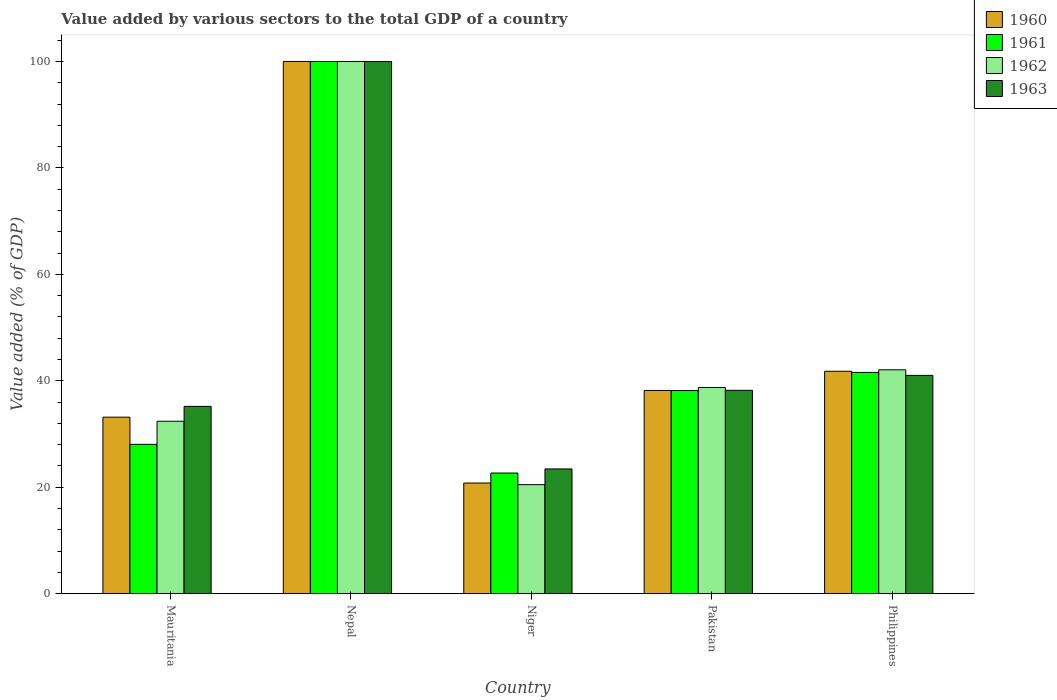How many different coloured bars are there?
Ensure brevity in your answer.  4. Are the number of bars per tick equal to the number of legend labels?
Provide a short and direct response. Yes. How many bars are there on the 2nd tick from the left?
Keep it short and to the point. 4. How many bars are there on the 1st tick from the right?
Your response must be concise. 4. What is the label of the 2nd group of bars from the left?
Offer a very short reply. Nepal. What is the value added by various sectors to the total GDP in 1963 in Nepal?
Ensure brevity in your answer.  100. Across all countries, what is the minimum value added by various sectors to the total GDP in 1960?
Make the answer very short. 20.79. In which country was the value added by various sectors to the total GDP in 1961 maximum?
Make the answer very short. Nepal. In which country was the value added by various sectors to the total GDP in 1960 minimum?
Give a very brief answer. Niger. What is the total value added by various sectors to the total GDP in 1962 in the graph?
Your answer should be very brief. 233.69. What is the difference between the value added by various sectors to the total GDP in 1963 in Niger and that in Philippines?
Offer a very short reply. -17.58. What is the difference between the value added by various sectors to the total GDP in 1963 in Mauritania and the value added by various sectors to the total GDP in 1961 in Philippines?
Offer a terse response. -6.38. What is the average value added by various sectors to the total GDP in 1962 per country?
Your answer should be compact. 46.74. What is the difference between the value added by various sectors to the total GDP of/in 1960 and value added by various sectors to the total GDP of/in 1962 in Pakistan?
Provide a succinct answer. -0.56. In how many countries, is the value added by various sectors to the total GDP in 1962 greater than 68 %?
Make the answer very short. 1. What is the ratio of the value added by various sectors to the total GDP in 1961 in Pakistan to that in Philippines?
Your answer should be very brief. 0.92. Is the value added by various sectors to the total GDP in 1960 in Mauritania less than that in Philippines?
Your answer should be compact. Yes. What is the difference between the highest and the second highest value added by various sectors to the total GDP in 1963?
Provide a succinct answer. -58.99. What is the difference between the highest and the lowest value added by various sectors to the total GDP in 1960?
Give a very brief answer. 79.21. Is the sum of the value added by various sectors to the total GDP in 1961 in Niger and Philippines greater than the maximum value added by various sectors to the total GDP in 1963 across all countries?
Your response must be concise. No. Is it the case that in every country, the sum of the value added by various sectors to the total GDP in 1961 and value added by various sectors to the total GDP in 1960 is greater than the sum of value added by various sectors to the total GDP in 1962 and value added by various sectors to the total GDP in 1963?
Offer a terse response. No. What does the 2nd bar from the left in Philippines represents?
Your answer should be very brief. 1961. What does the 1st bar from the right in Mauritania represents?
Your answer should be very brief. 1963. How many bars are there?
Provide a succinct answer. 20. Are all the bars in the graph horizontal?
Provide a short and direct response. No. How many countries are there in the graph?
Ensure brevity in your answer.  5. Does the graph contain any zero values?
Keep it short and to the point. No. How many legend labels are there?
Offer a terse response. 4. How are the legend labels stacked?
Keep it short and to the point. Vertical. What is the title of the graph?
Keep it short and to the point. Value added by various sectors to the total GDP of a country. Does "2012" appear as one of the legend labels in the graph?
Ensure brevity in your answer.  No. What is the label or title of the Y-axis?
Provide a succinct answer. Value added (% of GDP). What is the Value added (% of GDP) in 1960 in Mauritania?
Give a very brief answer. 33.17. What is the Value added (% of GDP) in 1961 in Mauritania?
Your answer should be compact. 28.06. What is the Value added (% of GDP) of 1962 in Mauritania?
Give a very brief answer. 32.4. What is the Value added (% of GDP) of 1963 in Mauritania?
Your answer should be compact. 35.19. What is the Value added (% of GDP) in 1961 in Nepal?
Make the answer very short. 100. What is the Value added (% of GDP) in 1960 in Niger?
Your response must be concise. 20.79. What is the Value added (% of GDP) of 1961 in Niger?
Make the answer very short. 22.67. What is the Value added (% of GDP) in 1962 in Niger?
Provide a short and direct response. 20.48. What is the Value added (% of GDP) of 1963 in Niger?
Your response must be concise. 23.44. What is the Value added (% of GDP) in 1960 in Pakistan?
Offer a terse response. 38.18. What is the Value added (% of GDP) in 1961 in Pakistan?
Give a very brief answer. 38.17. What is the Value added (% of GDP) in 1962 in Pakistan?
Your response must be concise. 38.74. What is the Value added (% of GDP) of 1963 in Pakistan?
Offer a very short reply. 38.21. What is the Value added (% of GDP) of 1960 in Philippines?
Provide a short and direct response. 41.79. What is the Value added (% of GDP) of 1961 in Philippines?
Make the answer very short. 41.57. What is the Value added (% of GDP) of 1962 in Philippines?
Offer a very short reply. 42.06. What is the Value added (% of GDP) in 1963 in Philippines?
Provide a succinct answer. 41.01. Across all countries, what is the maximum Value added (% of GDP) of 1962?
Offer a terse response. 100. Across all countries, what is the minimum Value added (% of GDP) of 1960?
Give a very brief answer. 20.79. Across all countries, what is the minimum Value added (% of GDP) of 1961?
Give a very brief answer. 22.67. Across all countries, what is the minimum Value added (% of GDP) of 1962?
Provide a short and direct response. 20.48. Across all countries, what is the minimum Value added (% of GDP) of 1963?
Give a very brief answer. 23.44. What is the total Value added (% of GDP) of 1960 in the graph?
Make the answer very short. 233.93. What is the total Value added (% of GDP) in 1961 in the graph?
Your response must be concise. 230.47. What is the total Value added (% of GDP) in 1962 in the graph?
Make the answer very short. 233.69. What is the total Value added (% of GDP) of 1963 in the graph?
Provide a short and direct response. 237.85. What is the difference between the Value added (% of GDP) in 1960 in Mauritania and that in Nepal?
Your answer should be very brief. -66.83. What is the difference between the Value added (% of GDP) in 1961 in Mauritania and that in Nepal?
Make the answer very short. -71.94. What is the difference between the Value added (% of GDP) in 1962 in Mauritania and that in Nepal?
Keep it short and to the point. -67.6. What is the difference between the Value added (% of GDP) of 1963 in Mauritania and that in Nepal?
Provide a short and direct response. -64.81. What is the difference between the Value added (% of GDP) of 1960 in Mauritania and that in Niger?
Ensure brevity in your answer.  12.38. What is the difference between the Value added (% of GDP) in 1961 in Mauritania and that in Niger?
Keep it short and to the point. 5.39. What is the difference between the Value added (% of GDP) in 1962 in Mauritania and that in Niger?
Offer a very short reply. 11.91. What is the difference between the Value added (% of GDP) in 1963 in Mauritania and that in Niger?
Provide a succinct answer. 11.75. What is the difference between the Value added (% of GDP) in 1960 in Mauritania and that in Pakistan?
Offer a terse response. -5.02. What is the difference between the Value added (% of GDP) of 1961 in Mauritania and that in Pakistan?
Your answer should be compact. -10.11. What is the difference between the Value added (% of GDP) of 1962 in Mauritania and that in Pakistan?
Your response must be concise. -6.35. What is the difference between the Value added (% of GDP) in 1963 in Mauritania and that in Pakistan?
Offer a very short reply. -3.02. What is the difference between the Value added (% of GDP) of 1960 in Mauritania and that in Philippines?
Provide a short and direct response. -8.63. What is the difference between the Value added (% of GDP) in 1961 in Mauritania and that in Philippines?
Keep it short and to the point. -13.52. What is the difference between the Value added (% of GDP) in 1962 in Mauritania and that in Philippines?
Offer a very short reply. -9.67. What is the difference between the Value added (% of GDP) of 1963 in Mauritania and that in Philippines?
Provide a short and direct response. -5.82. What is the difference between the Value added (% of GDP) in 1960 in Nepal and that in Niger?
Give a very brief answer. 79.21. What is the difference between the Value added (% of GDP) in 1961 in Nepal and that in Niger?
Give a very brief answer. 77.33. What is the difference between the Value added (% of GDP) in 1962 in Nepal and that in Niger?
Make the answer very short. 79.52. What is the difference between the Value added (% of GDP) of 1963 in Nepal and that in Niger?
Offer a very short reply. 76.56. What is the difference between the Value added (% of GDP) in 1960 in Nepal and that in Pakistan?
Provide a succinct answer. 61.82. What is the difference between the Value added (% of GDP) in 1961 in Nepal and that in Pakistan?
Keep it short and to the point. 61.83. What is the difference between the Value added (% of GDP) of 1962 in Nepal and that in Pakistan?
Keep it short and to the point. 61.26. What is the difference between the Value added (% of GDP) in 1963 in Nepal and that in Pakistan?
Your answer should be compact. 61.79. What is the difference between the Value added (% of GDP) of 1960 in Nepal and that in Philippines?
Offer a terse response. 58.21. What is the difference between the Value added (% of GDP) of 1961 in Nepal and that in Philippines?
Offer a terse response. 58.42. What is the difference between the Value added (% of GDP) of 1962 in Nepal and that in Philippines?
Your answer should be compact. 57.94. What is the difference between the Value added (% of GDP) of 1963 in Nepal and that in Philippines?
Give a very brief answer. 58.99. What is the difference between the Value added (% of GDP) in 1960 in Niger and that in Pakistan?
Make the answer very short. -17.39. What is the difference between the Value added (% of GDP) in 1961 in Niger and that in Pakistan?
Make the answer very short. -15.5. What is the difference between the Value added (% of GDP) of 1962 in Niger and that in Pakistan?
Offer a very short reply. -18.26. What is the difference between the Value added (% of GDP) of 1963 in Niger and that in Pakistan?
Keep it short and to the point. -14.77. What is the difference between the Value added (% of GDP) in 1960 in Niger and that in Philippines?
Offer a very short reply. -21. What is the difference between the Value added (% of GDP) of 1961 in Niger and that in Philippines?
Keep it short and to the point. -18.91. What is the difference between the Value added (% of GDP) of 1962 in Niger and that in Philippines?
Make the answer very short. -21.58. What is the difference between the Value added (% of GDP) of 1963 in Niger and that in Philippines?
Your answer should be very brief. -17.58. What is the difference between the Value added (% of GDP) of 1960 in Pakistan and that in Philippines?
Give a very brief answer. -3.61. What is the difference between the Value added (% of GDP) of 1961 in Pakistan and that in Philippines?
Make the answer very short. -3.41. What is the difference between the Value added (% of GDP) in 1962 in Pakistan and that in Philippines?
Your answer should be very brief. -3.32. What is the difference between the Value added (% of GDP) in 1963 in Pakistan and that in Philippines?
Offer a very short reply. -2.81. What is the difference between the Value added (% of GDP) of 1960 in Mauritania and the Value added (% of GDP) of 1961 in Nepal?
Ensure brevity in your answer.  -66.83. What is the difference between the Value added (% of GDP) in 1960 in Mauritania and the Value added (% of GDP) in 1962 in Nepal?
Make the answer very short. -66.83. What is the difference between the Value added (% of GDP) of 1960 in Mauritania and the Value added (% of GDP) of 1963 in Nepal?
Offer a very short reply. -66.83. What is the difference between the Value added (% of GDP) of 1961 in Mauritania and the Value added (% of GDP) of 1962 in Nepal?
Keep it short and to the point. -71.94. What is the difference between the Value added (% of GDP) of 1961 in Mauritania and the Value added (% of GDP) of 1963 in Nepal?
Your answer should be compact. -71.94. What is the difference between the Value added (% of GDP) in 1962 in Mauritania and the Value added (% of GDP) in 1963 in Nepal?
Your answer should be compact. -67.6. What is the difference between the Value added (% of GDP) in 1960 in Mauritania and the Value added (% of GDP) in 1961 in Niger?
Provide a short and direct response. 10.5. What is the difference between the Value added (% of GDP) in 1960 in Mauritania and the Value added (% of GDP) in 1962 in Niger?
Keep it short and to the point. 12.68. What is the difference between the Value added (% of GDP) in 1960 in Mauritania and the Value added (% of GDP) in 1963 in Niger?
Offer a terse response. 9.73. What is the difference between the Value added (% of GDP) in 1961 in Mauritania and the Value added (% of GDP) in 1962 in Niger?
Your answer should be very brief. 7.58. What is the difference between the Value added (% of GDP) in 1961 in Mauritania and the Value added (% of GDP) in 1963 in Niger?
Ensure brevity in your answer.  4.62. What is the difference between the Value added (% of GDP) in 1962 in Mauritania and the Value added (% of GDP) in 1963 in Niger?
Keep it short and to the point. 8.96. What is the difference between the Value added (% of GDP) in 1960 in Mauritania and the Value added (% of GDP) in 1961 in Pakistan?
Provide a succinct answer. -5. What is the difference between the Value added (% of GDP) of 1960 in Mauritania and the Value added (% of GDP) of 1962 in Pakistan?
Offer a terse response. -5.58. What is the difference between the Value added (% of GDP) in 1960 in Mauritania and the Value added (% of GDP) in 1963 in Pakistan?
Provide a succinct answer. -5.04. What is the difference between the Value added (% of GDP) of 1961 in Mauritania and the Value added (% of GDP) of 1962 in Pakistan?
Give a very brief answer. -10.69. What is the difference between the Value added (% of GDP) of 1961 in Mauritania and the Value added (% of GDP) of 1963 in Pakistan?
Keep it short and to the point. -10.15. What is the difference between the Value added (% of GDP) in 1962 in Mauritania and the Value added (% of GDP) in 1963 in Pakistan?
Offer a terse response. -5.81. What is the difference between the Value added (% of GDP) in 1960 in Mauritania and the Value added (% of GDP) in 1961 in Philippines?
Keep it short and to the point. -8.41. What is the difference between the Value added (% of GDP) in 1960 in Mauritania and the Value added (% of GDP) in 1962 in Philippines?
Your response must be concise. -8.9. What is the difference between the Value added (% of GDP) of 1960 in Mauritania and the Value added (% of GDP) of 1963 in Philippines?
Your answer should be very brief. -7.85. What is the difference between the Value added (% of GDP) of 1961 in Mauritania and the Value added (% of GDP) of 1962 in Philippines?
Ensure brevity in your answer.  -14. What is the difference between the Value added (% of GDP) of 1961 in Mauritania and the Value added (% of GDP) of 1963 in Philippines?
Offer a very short reply. -12.96. What is the difference between the Value added (% of GDP) of 1962 in Mauritania and the Value added (% of GDP) of 1963 in Philippines?
Keep it short and to the point. -8.62. What is the difference between the Value added (% of GDP) in 1960 in Nepal and the Value added (% of GDP) in 1961 in Niger?
Make the answer very short. 77.33. What is the difference between the Value added (% of GDP) of 1960 in Nepal and the Value added (% of GDP) of 1962 in Niger?
Offer a very short reply. 79.52. What is the difference between the Value added (% of GDP) in 1960 in Nepal and the Value added (% of GDP) in 1963 in Niger?
Offer a very short reply. 76.56. What is the difference between the Value added (% of GDP) in 1961 in Nepal and the Value added (% of GDP) in 1962 in Niger?
Keep it short and to the point. 79.52. What is the difference between the Value added (% of GDP) in 1961 in Nepal and the Value added (% of GDP) in 1963 in Niger?
Provide a succinct answer. 76.56. What is the difference between the Value added (% of GDP) in 1962 in Nepal and the Value added (% of GDP) in 1963 in Niger?
Give a very brief answer. 76.56. What is the difference between the Value added (% of GDP) of 1960 in Nepal and the Value added (% of GDP) of 1961 in Pakistan?
Offer a very short reply. 61.83. What is the difference between the Value added (% of GDP) in 1960 in Nepal and the Value added (% of GDP) in 1962 in Pakistan?
Your answer should be very brief. 61.26. What is the difference between the Value added (% of GDP) in 1960 in Nepal and the Value added (% of GDP) in 1963 in Pakistan?
Provide a succinct answer. 61.79. What is the difference between the Value added (% of GDP) of 1961 in Nepal and the Value added (% of GDP) of 1962 in Pakistan?
Offer a very short reply. 61.26. What is the difference between the Value added (% of GDP) in 1961 in Nepal and the Value added (% of GDP) in 1963 in Pakistan?
Your answer should be compact. 61.79. What is the difference between the Value added (% of GDP) of 1962 in Nepal and the Value added (% of GDP) of 1963 in Pakistan?
Provide a short and direct response. 61.79. What is the difference between the Value added (% of GDP) in 1960 in Nepal and the Value added (% of GDP) in 1961 in Philippines?
Make the answer very short. 58.42. What is the difference between the Value added (% of GDP) of 1960 in Nepal and the Value added (% of GDP) of 1962 in Philippines?
Your answer should be compact. 57.94. What is the difference between the Value added (% of GDP) in 1960 in Nepal and the Value added (% of GDP) in 1963 in Philippines?
Ensure brevity in your answer.  58.99. What is the difference between the Value added (% of GDP) of 1961 in Nepal and the Value added (% of GDP) of 1962 in Philippines?
Your answer should be very brief. 57.94. What is the difference between the Value added (% of GDP) of 1961 in Nepal and the Value added (% of GDP) of 1963 in Philippines?
Provide a succinct answer. 58.99. What is the difference between the Value added (% of GDP) of 1962 in Nepal and the Value added (% of GDP) of 1963 in Philippines?
Keep it short and to the point. 58.99. What is the difference between the Value added (% of GDP) in 1960 in Niger and the Value added (% of GDP) in 1961 in Pakistan?
Your answer should be compact. -17.38. What is the difference between the Value added (% of GDP) of 1960 in Niger and the Value added (% of GDP) of 1962 in Pakistan?
Provide a short and direct response. -17.95. What is the difference between the Value added (% of GDP) of 1960 in Niger and the Value added (% of GDP) of 1963 in Pakistan?
Offer a very short reply. -17.42. What is the difference between the Value added (% of GDP) of 1961 in Niger and the Value added (% of GDP) of 1962 in Pakistan?
Make the answer very short. -16.08. What is the difference between the Value added (% of GDP) of 1961 in Niger and the Value added (% of GDP) of 1963 in Pakistan?
Ensure brevity in your answer.  -15.54. What is the difference between the Value added (% of GDP) of 1962 in Niger and the Value added (% of GDP) of 1963 in Pakistan?
Make the answer very short. -17.73. What is the difference between the Value added (% of GDP) of 1960 in Niger and the Value added (% of GDP) of 1961 in Philippines?
Your answer should be compact. -20.78. What is the difference between the Value added (% of GDP) in 1960 in Niger and the Value added (% of GDP) in 1962 in Philippines?
Provide a short and direct response. -21.27. What is the difference between the Value added (% of GDP) of 1960 in Niger and the Value added (% of GDP) of 1963 in Philippines?
Offer a very short reply. -20.22. What is the difference between the Value added (% of GDP) of 1961 in Niger and the Value added (% of GDP) of 1962 in Philippines?
Ensure brevity in your answer.  -19.4. What is the difference between the Value added (% of GDP) of 1961 in Niger and the Value added (% of GDP) of 1963 in Philippines?
Keep it short and to the point. -18.35. What is the difference between the Value added (% of GDP) in 1962 in Niger and the Value added (% of GDP) in 1963 in Philippines?
Provide a succinct answer. -20.53. What is the difference between the Value added (% of GDP) of 1960 in Pakistan and the Value added (% of GDP) of 1961 in Philippines?
Your answer should be very brief. -3.39. What is the difference between the Value added (% of GDP) of 1960 in Pakistan and the Value added (% of GDP) of 1962 in Philippines?
Ensure brevity in your answer.  -3.88. What is the difference between the Value added (% of GDP) in 1960 in Pakistan and the Value added (% of GDP) in 1963 in Philippines?
Offer a terse response. -2.83. What is the difference between the Value added (% of GDP) in 1961 in Pakistan and the Value added (% of GDP) in 1962 in Philippines?
Your response must be concise. -3.89. What is the difference between the Value added (% of GDP) in 1961 in Pakistan and the Value added (% of GDP) in 1963 in Philippines?
Keep it short and to the point. -2.85. What is the difference between the Value added (% of GDP) of 1962 in Pakistan and the Value added (% of GDP) of 1963 in Philippines?
Make the answer very short. -2.27. What is the average Value added (% of GDP) in 1960 per country?
Offer a terse response. 46.79. What is the average Value added (% of GDP) of 1961 per country?
Ensure brevity in your answer.  46.09. What is the average Value added (% of GDP) in 1962 per country?
Give a very brief answer. 46.74. What is the average Value added (% of GDP) in 1963 per country?
Give a very brief answer. 47.57. What is the difference between the Value added (% of GDP) of 1960 and Value added (% of GDP) of 1961 in Mauritania?
Offer a very short reply. 5.11. What is the difference between the Value added (% of GDP) in 1960 and Value added (% of GDP) in 1962 in Mauritania?
Provide a succinct answer. 0.77. What is the difference between the Value added (% of GDP) of 1960 and Value added (% of GDP) of 1963 in Mauritania?
Provide a succinct answer. -2.02. What is the difference between the Value added (% of GDP) in 1961 and Value added (% of GDP) in 1962 in Mauritania?
Give a very brief answer. -4.34. What is the difference between the Value added (% of GDP) in 1961 and Value added (% of GDP) in 1963 in Mauritania?
Your response must be concise. -7.13. What is the difference between the Value added (% of GDP) in 1962 and Value added (% of GDP) in 1963 in Mauritania?
Your answer should be compact. -2.79. What is the difference between the Value added (% of GDP) of 1960 and Value added (% of GDP) of 1961 in Nepal?
Offer a very short reply. 0. What is the difference between the Value added (% of GDP) in 1961 and Value added (% of GDP) in 1962 in Nepal?
Provide a succinct answer. 0. What is the difference between the Value added (% of GDP) of 1961 and Value added (% of GDP) of 1963 in Nepal?
Make the answer very short. 0. What is the difference between the Value added (% of GDP) in 1960 and Value added (% of GDP) in 1961 in Niger?
Keep it short and to the point. -1.88. What is the difference between the Value added (% of GDP) in 1960 and Value added (% of GDP) in 1962 in Niger?
Provide a short and direct response. 0.31. What is the difference between the Value added (% of GDP) of 1960 and Value added (% of GDP) of 1963 in Niger?
Make the answer very short. -2.65. What is the difference between the Value added (% of GDP) in 1961 and Value added (% of GDP) in 1962 in Niger?
Your response must be concise. 2.18. What is the difference between the Value added (% of GDP) of 1961 and Value added (% of GDP) of 1963 in Niger?
Give a very brief answer. -0.77. What is the difference between the Value added (% of GDP) of 1962 and Value added (% of GDP) of 1963 in Niger?
Give a very brief answer. -2.96. What is the difference between the Value added (% of GDP) in 1960 and Value added (% of GDP) in 1961 in Pakistan?
Make the answer very short. 0.01. What is the difference between the Value added (% of GDP) in 1960 and Value added (% of GDP) in 1962 in Pakistan?
Keep it short and to the point. -0.56. What is the difference between the Value added (% of GDP) of 1960 and Value added (% of GDP) of 1963 in Pakistan?
Offer a very short reply. -0.03. What is the difference between the Value added (% of GDP) of 1961 and Value added (% of GDP) of 1962 in Pakistan?
Your answer should be very brief. -0.58. What is the difference between the Value added (% of GDP) of 1961 and Value added (% of GDP) of 1963 in Pakistan?
Provide a short and direct response. -0.04. What is the difference between the Value added (% of GDP) in 1962 and Value added (% of GDP) in 1963 in Pakistan?
Ensure brevity in your answer.  0.53. What is the difference between the Value added (% of GDP) of 1960 and Value added (% of GDP) of 1961 in Philippines?
Your answer should be very brief. 0.22. What is the difference between the Value added (% of GDP) in 1960 and Value added (% of GDP) in 1962 in Philippines?
Offer a very short reply. -0.27. What is the difference between the Value added (% of GDP) of 1960 and Value added (% of GDP) of 1963 in Philippines?
Your answer should be compact. 0.78. What is the difference between the Value added (% of GDP) of 1961 and Value added (% of GDP) of 1962 in Philippines?
Provide a short and direct response. -0.49. What is the difference between the Value added (% of GDP) of 1961 and Value added (% of GDP) of 1963 in Philippines?
Your answer should be very brief. 0.56. What is the difference between the Value added (% of GDP) of 1962 and Value added (% of GDP) of 1963 in Philippines?
Your answer should be very brief. 1.05. What is the ratio of the Value added (% of GDP) in 1960 in Mauritania to that in Nepal?
Ensure brevity in your answer.  0.33. What is the ratio of the Value added (% of GDP) in 1961 in Mauritania to that in Nepal?
Keep it short and to the point. 0.28. What is the ratio of the Value added (% of GDP) of 1962 in Mauritania to that in Nepal?
Offer a very short reply. 0.32. What is the ratio of the Value added (% of GDP) of 1963 in Mauritania to that in Nepal?
Your response must be concise. 0.35. What is the ratio of the Value added (% of GDP) of 1960 in Mauritania to that in Niger?
Your answer should be compact. 1.6. What is the ratio of the Value added (% of GDP) of 1961 in Mauritania to that in Niger?
Your answer should be very brief. 1.24. What is the ratio of the Value added (% of GDP) of 1962 in Mauritania to that in Niger?
Provide a succinct answer. 1.58. What is the ratio of the Value added (% of GDP) of 1963 in Mauritania to that in Niger?
Offer a very short reply. 1.5. What is the ratio of the Value added (% of GDP) in 1960 in Mauritania to that in Pakistan?
Keep it short and to the point. 0.87. What is the ratio of the Value added (% of GDP) of 1961 in Mauritania to that in Pakistan?
Your response must be concise. 0.74. What is the ratio of the Value added (% of GDP) of 1962 in Mauritania to that in Pakistan?
Offer a very short reply. 0.84. What is the ratio of the Value added (% of GDP) of 1963 in Mauritania to that in Pakistan?
Your answer should be very brief. 0.92. What is the ratio of the Value added (% of GDP) of 1960 in Mauritania to that in Philippines?
Your response must be concise. 0.79. What is the ratio of the Value added (% of GDP) in 1961 in Mauritania to that in Philippines?
Your answer should be compact. 0.67. What is the ratio of the Value added (% of GDP) of 1962 in Mauritania to that in Philippines?
Provide a succinct answer. 0.77. What is the ratio of the Value added (% of GDP) of 1963 in Mauritania to that in Philippines?
Keep it short and to the point. 0.86. What is the ratio of the Value added (% of GDP) of 1960 in Nepal to that in Niger?
Provide a succinct answer. 4.81. What is the ratio of the Value added (% of GDP) of 1961 in Nepal to that in Niger?
Your answer should be compact. 4.41. What is the ratio of the Value added (% of GDP) of 1962 in Nepal to that in Niger?
Offer a very short reply. 4.88. What is the ratio of the Value added (% of GDP) in 1963 in Nepal to that in Niger?
Provide a succinct answer. 4.27. What is the ratio of the Value added (% of GDP) in 1960 in Nepal to that in Pakistan?
Make the answer very short. 2.62. What is the ratio of the Value added (% of GDP) of 1961 in Nepal to that in Pakistan?
Your answer should be very brief. 2.62. What is the ratio of the Value added (% of GDP) of 1962 in Nepal to that in Pakistan?
Offer a very short reply. 2.58. What is the ratio of the Value added (% of GDP) in 1963 in Nepal to that in Pakistan?
Ensure brevity in your answer.  2.62. What is the ratio of the Value added (% of GDP) in 1960 in Nepal to that in Philippines?
Offer a terse response. 2.39. What is the ratio of the Value added (% of GDP) of 1961 in Nepal to that in Philippines?
Ensure brevity in your answer.  2.41. What is the ratio of the Value added (% of GDP) of 1962 in Nepal to that in Philippines?
Offer a very short reply. 2.38. What is the ratio of the Value added (% of GDP) of 1963 in Nepal to that in Philippines?
Ensure brevity in your answer.  2.44. What is the ratio of the Value added (% of GDP) in 1960 in Niger to that in Pakistan?
Your answer should be compact. 0.54. What is the ratio of the Value added (% of GDP) of 1961 in Niger to that in Pakistan?
Keep it short and to the point. 0.59. What is the ratio of the Value added (% of GDP) in 1962 in Niger to that in Pakistan?
Offer a terse response. 0.53. What is the ratio of the Value added (% of GDP) in 1963 in Niger to that in Pakistan?
Keep it short and to the point. 0.61. What is the ratio of the Value added (% of GDP) of 1960 in Niger to that in Philippines?
Your answer should be very brief. 0.5. What is the ratio of the Value added (% of GDP) in 1961 in Niger to that in Philippines?
Your answer should be compact. 0.55. What is the ratio of the Value added (% of GDP) of 1962 in Niger to that in Philippines?
Ensure brevity in your answer.  0.49. What is the ratio of the Value added (% of GDP) in 1963 in Niger to that in Philippines?
Make the answer very short. 0.57. What is the ratio of the Value added (% of GDP) in 1960 in Pakistan to that in Philippines?
Your response must be concise. 0.91. What is the ratio of the Value added (% of GDP) of 1961 in Pakistan to that in Philippines?
Provide a succinct answer. 0.92. What is the ratio of the Value added (% of GDP) of 1962 in Pakistan to that in Philippines?
Your answer should be very brief. 0.92. What is the ratio of the Value added (% of GDP) in 1963 in Pakistan to that in Philippines?
Offer a terse response. 0.93. What is the difference between the highest and the second highest Value added (% of GDP) in 1960?
Your answer should be very brief. 58.21. What is the difference between the highest and the second highest Value added (% of GDP) in 1961?
Your response must be concise. 58.42. What is the difference between the highest and the second highest Value added (% of GDP) in 1962?
Ensure brevity in your answer.  57.94. What is the difference between the highest and the second highest Value added (% of GDP) of 1963?
Make the answer very short. 58.99. What is the difference between the highest and the lowest Value added (% of GDP) in 1960?
Provide a succinct answer. 79.21. What is the difference between the highest and the lowest Value added (% of GDP) of 1961?
Make the answer very short. 77.33. What is the difference between the highest and the lowest Value added (% of GDP) in 1962?
Your response must be concise. 79.52. What is the difference between the highest and the lowest Value added (% of GDP) of 1963?
Keep it short and to the point. 76.56. 